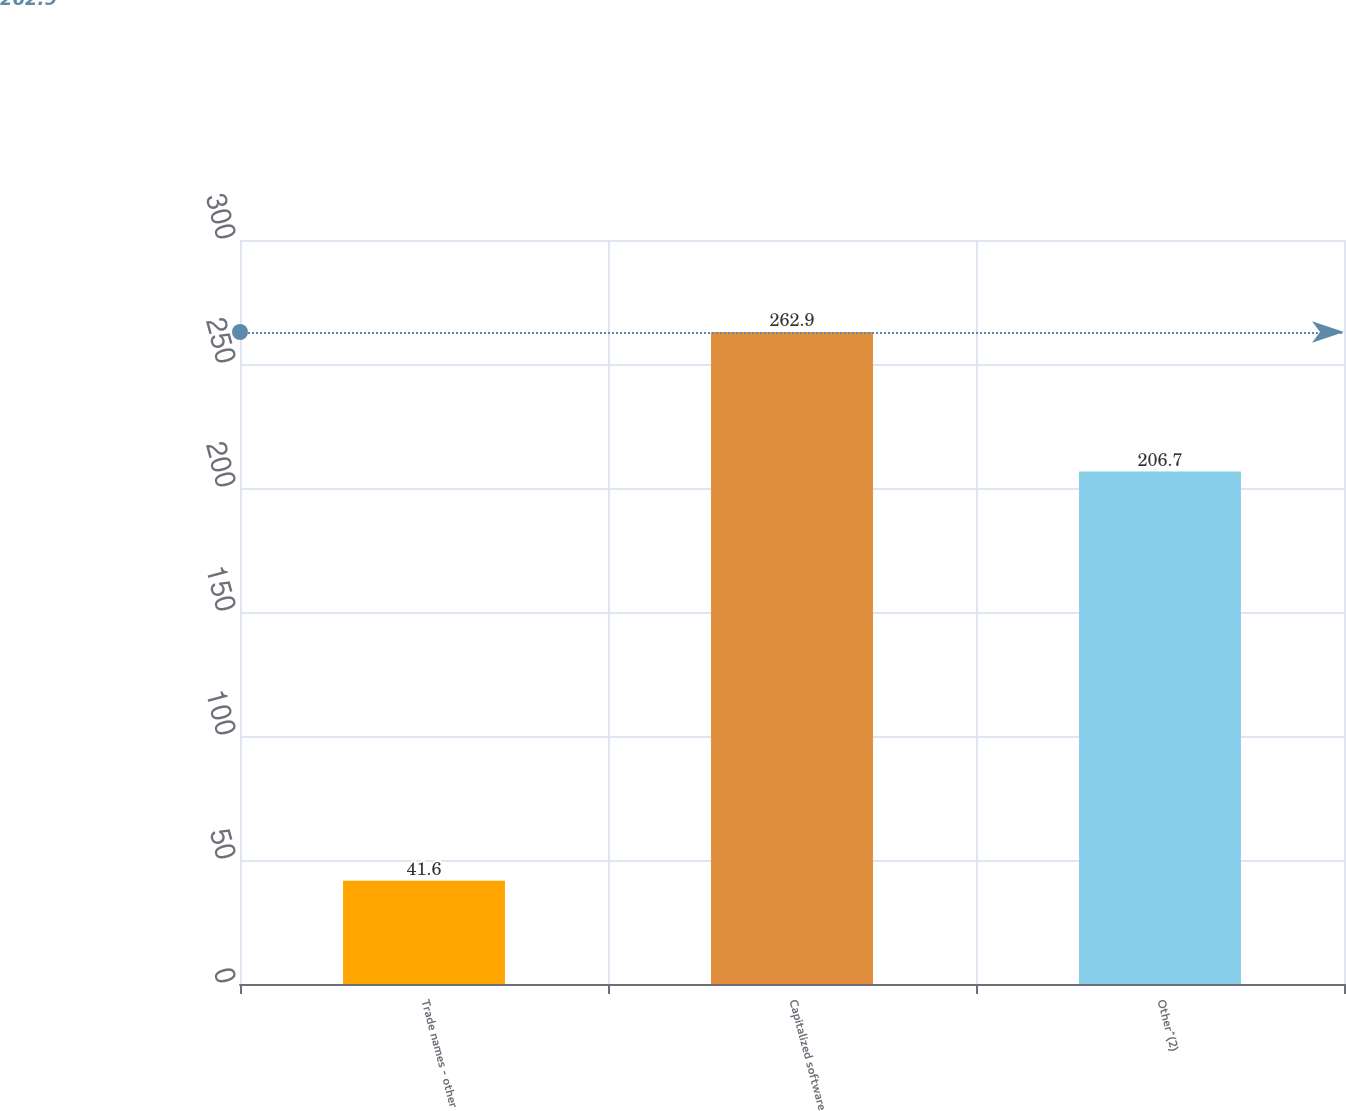Convert chart to OTSL. <chart><loc_0><loc_0><loc_500><loc_500><bar_chart><fcel>Trade names - other<fcel>Capitalized software<fcel>Other^(2)<nl><fcel>41.6<fcel>262.9<fcel>206.7<nl></chart> 